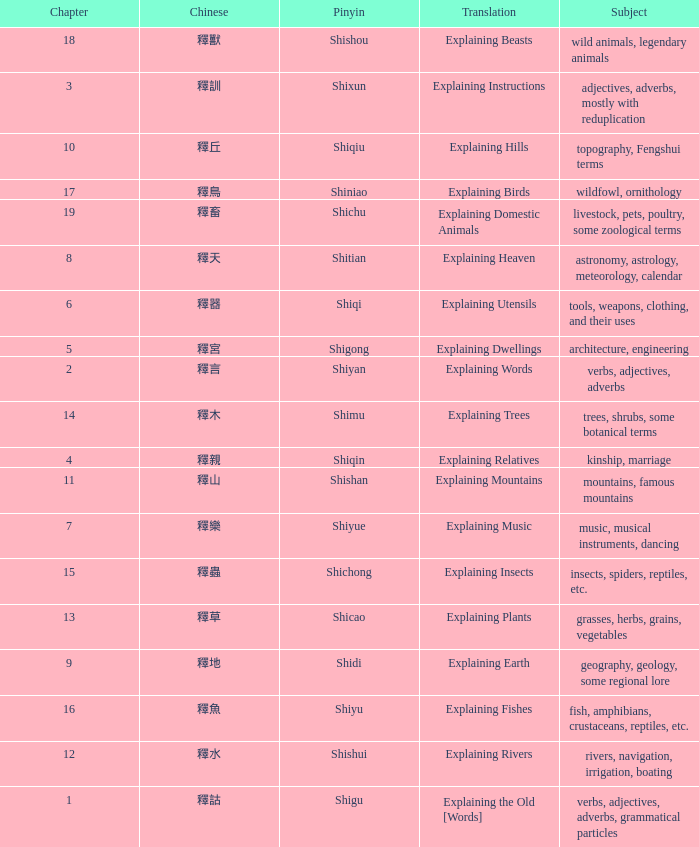Name the subject of shiyan Verbs, adjectives, adverbs. 